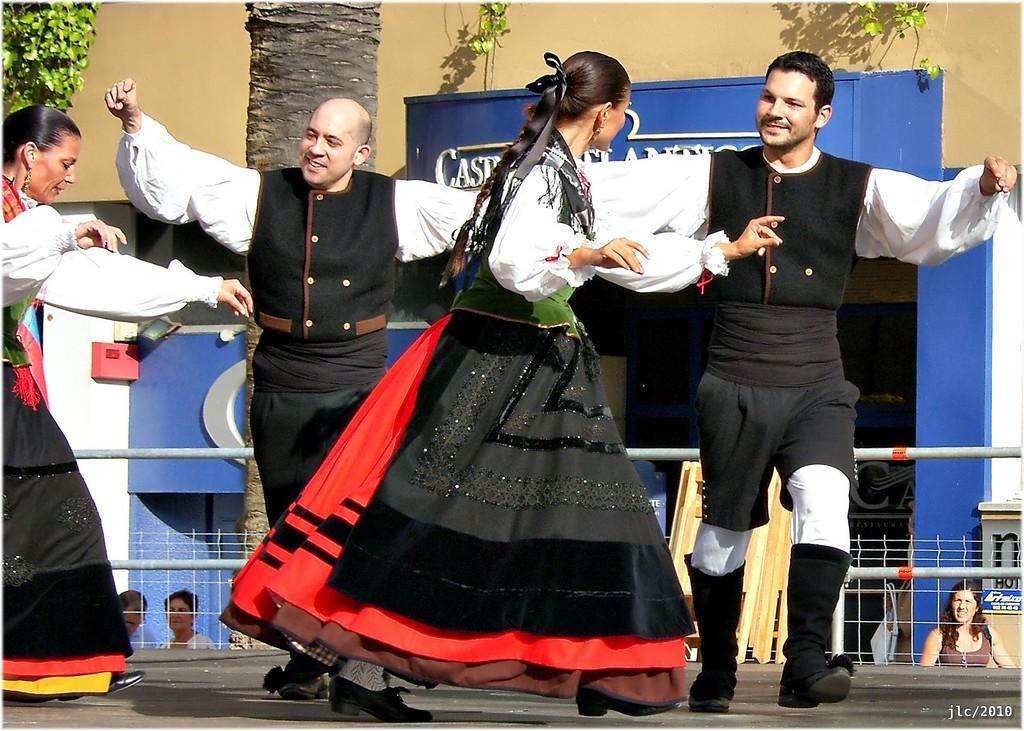Can you describe this image briefly? In this picture I can see people dancing on the floor. I can see the tree. I can see the metal grill fence. 